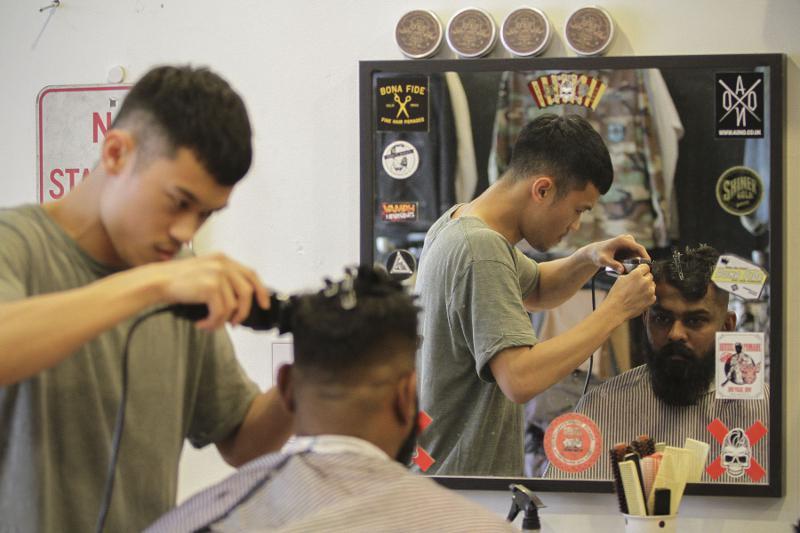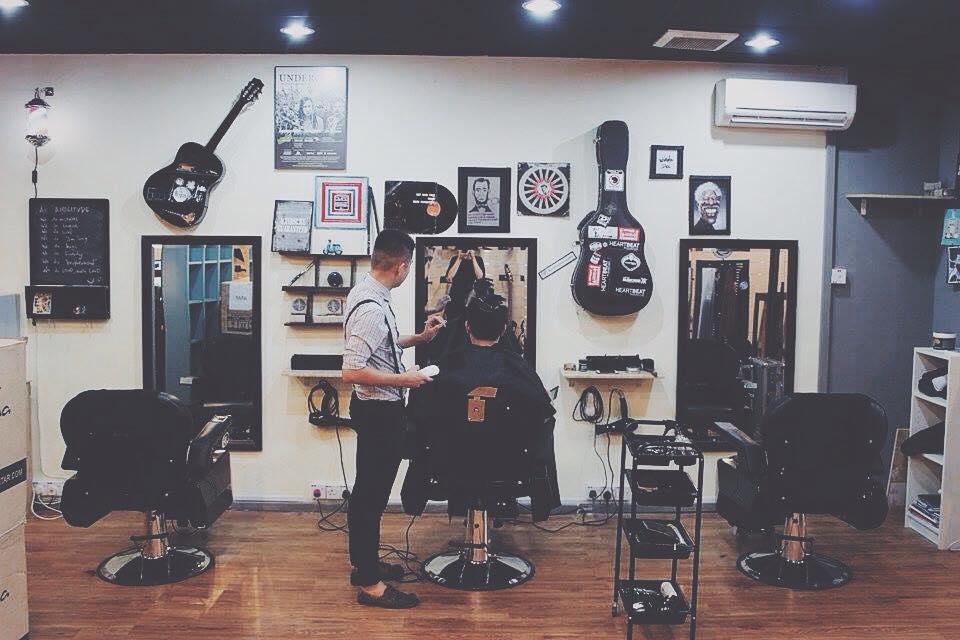The first image is the image on the left, the second image is the image on the right. Evaluate the accuracy of this statement regarding the images: "There are more than four people.". Is it true? Answer yes or no. No. The first image is the image on the left, the second image is the image on the right. Examine the images to the left and right. Is the description "There are no more than four people in the barber shop." accurate? Answer yes or no. Yes. 